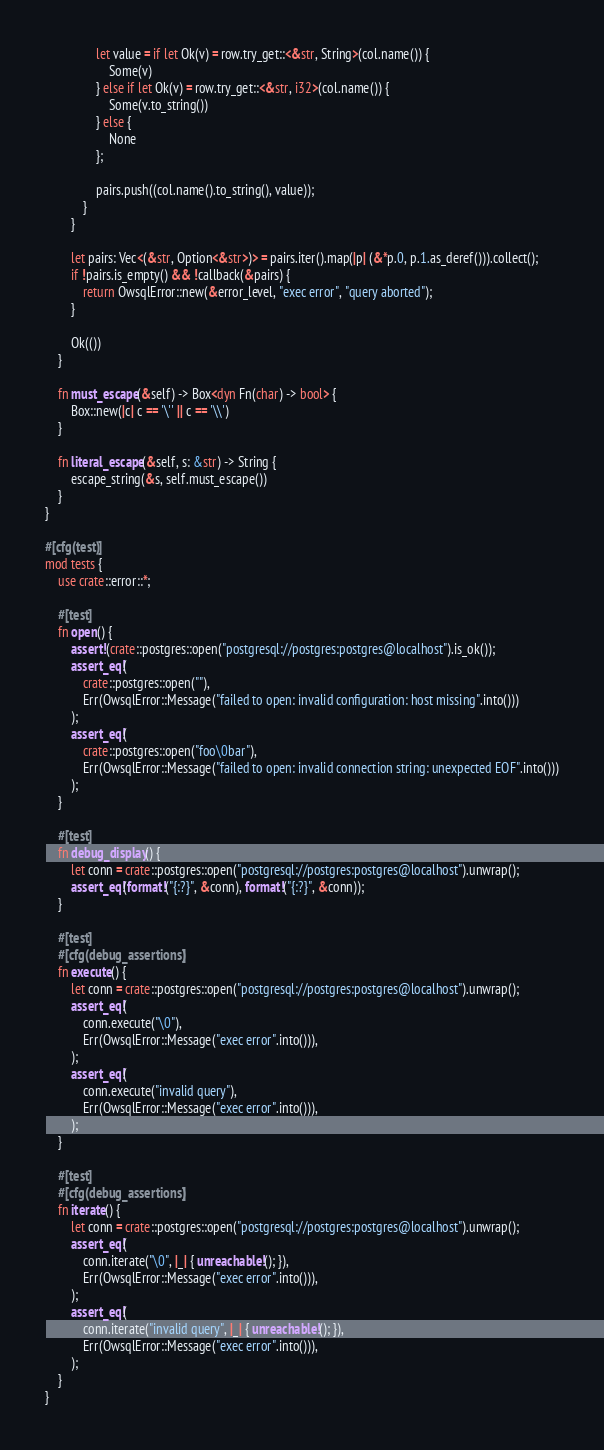Convert code to text. <code><loc_0><loc_0><loc_500><loc_500><_Rust_>                let value = if let Ok(v) = row.try_get::<&str, String>(col.name()) {
                    Some(v)
                } else if let Ok(v) = row.try_get::<&str, i32>(col.name()) {
                    Some(v.to_string())
                } else {
                    None
                };

                pairs.push((col.name().to_string(), value));
            }
        }

        let pairs: Vec<(&str, Option<&str>)> = pairs.iter().map(|p| (&*p.0, p.1.as_deref())).collect();
        if !pairs.is_empty() && !callback(&pairs) {
            return OwsqlError::new(&error_level, "exec error", "query aborted");
        }

        Ok(())
    }

    fn must_escape(&self) -> Box<dyn Fn(char) -> bool> {
        Box::new(|c| c == '\'' || c == '\\')
    }

    fn literal_escape(&self, s: &str) -> String {
        escape_string(&s, self.must_escape())
    }
}

#[cfg(test)]
mod tests {
    use crate::error::*;

    #[test]
    fn open() {
        assert!(crate::postgres::open("postgresql://postgres:postgres@localhost").is_ok());
        assert_eq!(
            crate::postgres::open(""),
            Err(OwsqlError::Message("failed to open: invalid configuration: host missing".into()))
        );
        assert_eq!(
            crate::postgres::open("foo\0bar"),
            Err(OwsqlError::Message("failed to open: invalid connection string: unexpected EOF".into()))
        );
    }

    #[test]
    fn debug_display() {
        let conn = crate::postgres::open("postgresql://postgres:postgres@localhost").unwrap();
        assert_eq!(format!("{:?}", &conn), format!("{:?}", &conn));
    }

    #[test]
    #[cfg(debug_assertions)]
    fn execute() {
        let conn = crate::postgres::open("postgresql://postgres:postgres@localhost").unwrap();
        assert_eq!(
            conn.execute("\0"),
            Err(OwsqlError::Message("exec error".into())),
        );
        assert_eq!(
            conn.execute("invalid query"),
            Err(OwsqlError::Message("exec error".into())),
        );
    }

    #[test]
    #[cfg(debug_assertions)]
    fn iterate() {
        let conn = crate::postgres::open("postgresql://postgres:postgres@localhost").unwrap();
        assert_eq!(
            conn.iterate("\0", |_| { unreachable!(); }),
            Err(OwsqlError::Message("exec error".into())),
        );
        assert_eq!(
            conn.iterate("invalid query", |_| { unreachable!(); }),
            Err(OwsqlError::Message("exec error".into())),
        );
    }
}
</code> 